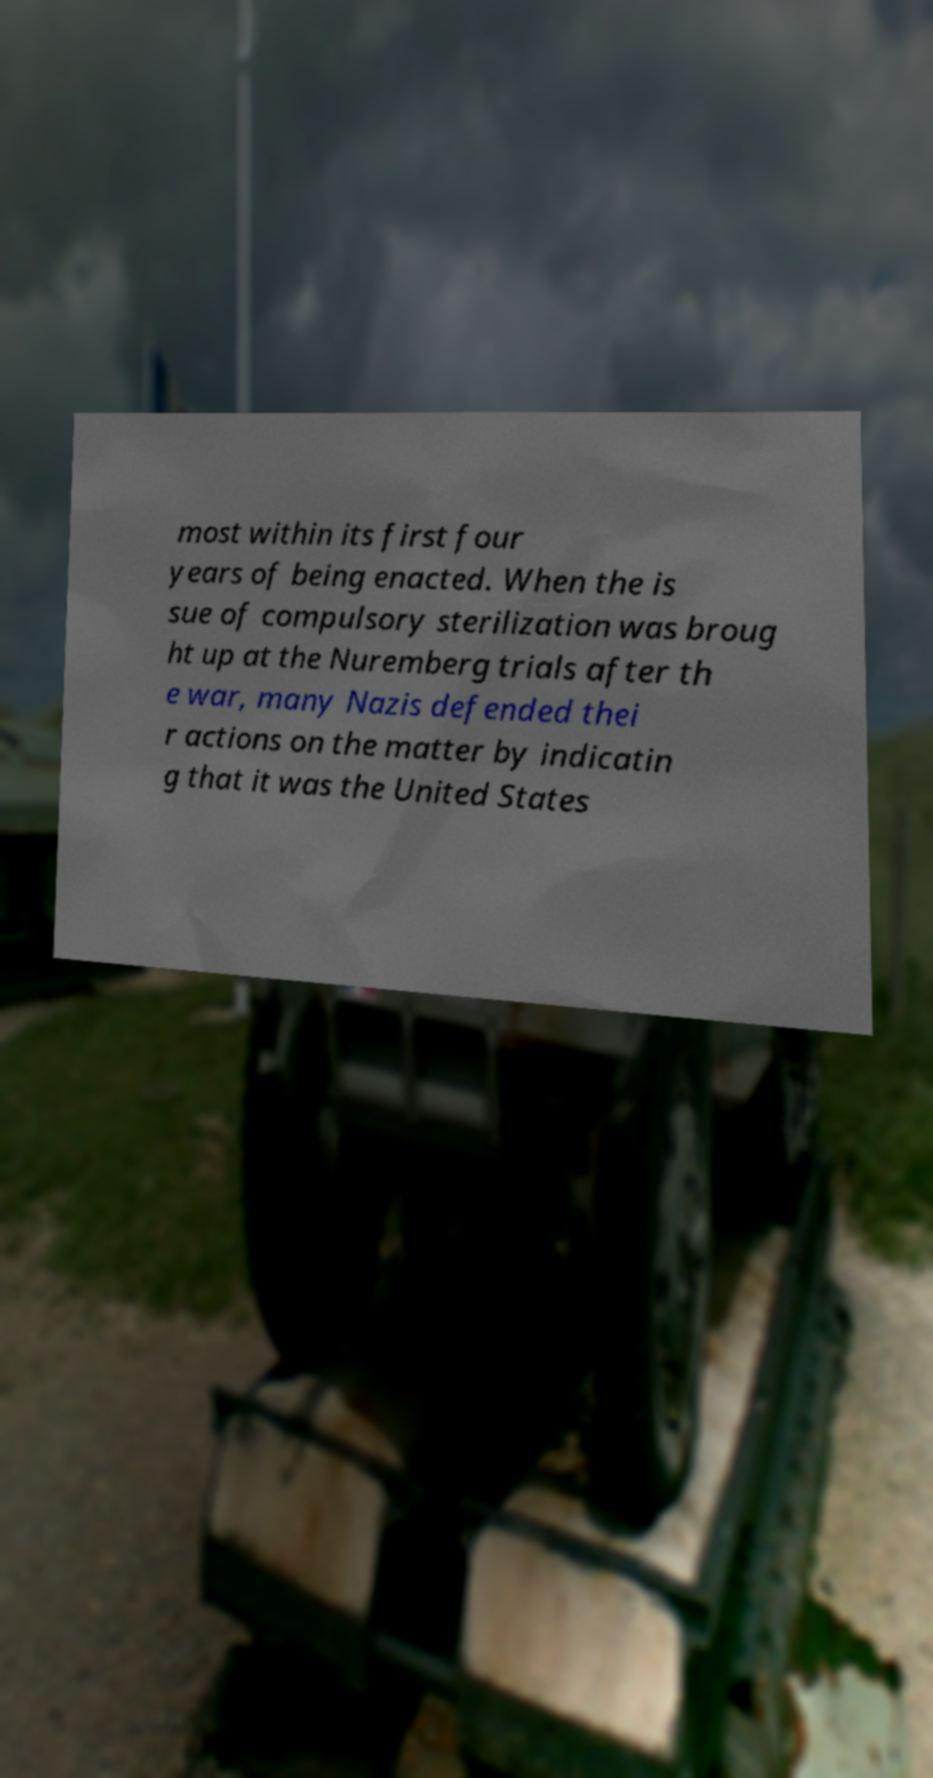There's text embedded in this image that I need extracted. Can you transcribe it verbatim? most within its first four years of being enacted. When the is sue of compulsory sterilization was broug ht up at the Nuremberg trials after th e war, many Nazis defended thei r actions on the matter by indicatin g that it was the United States 